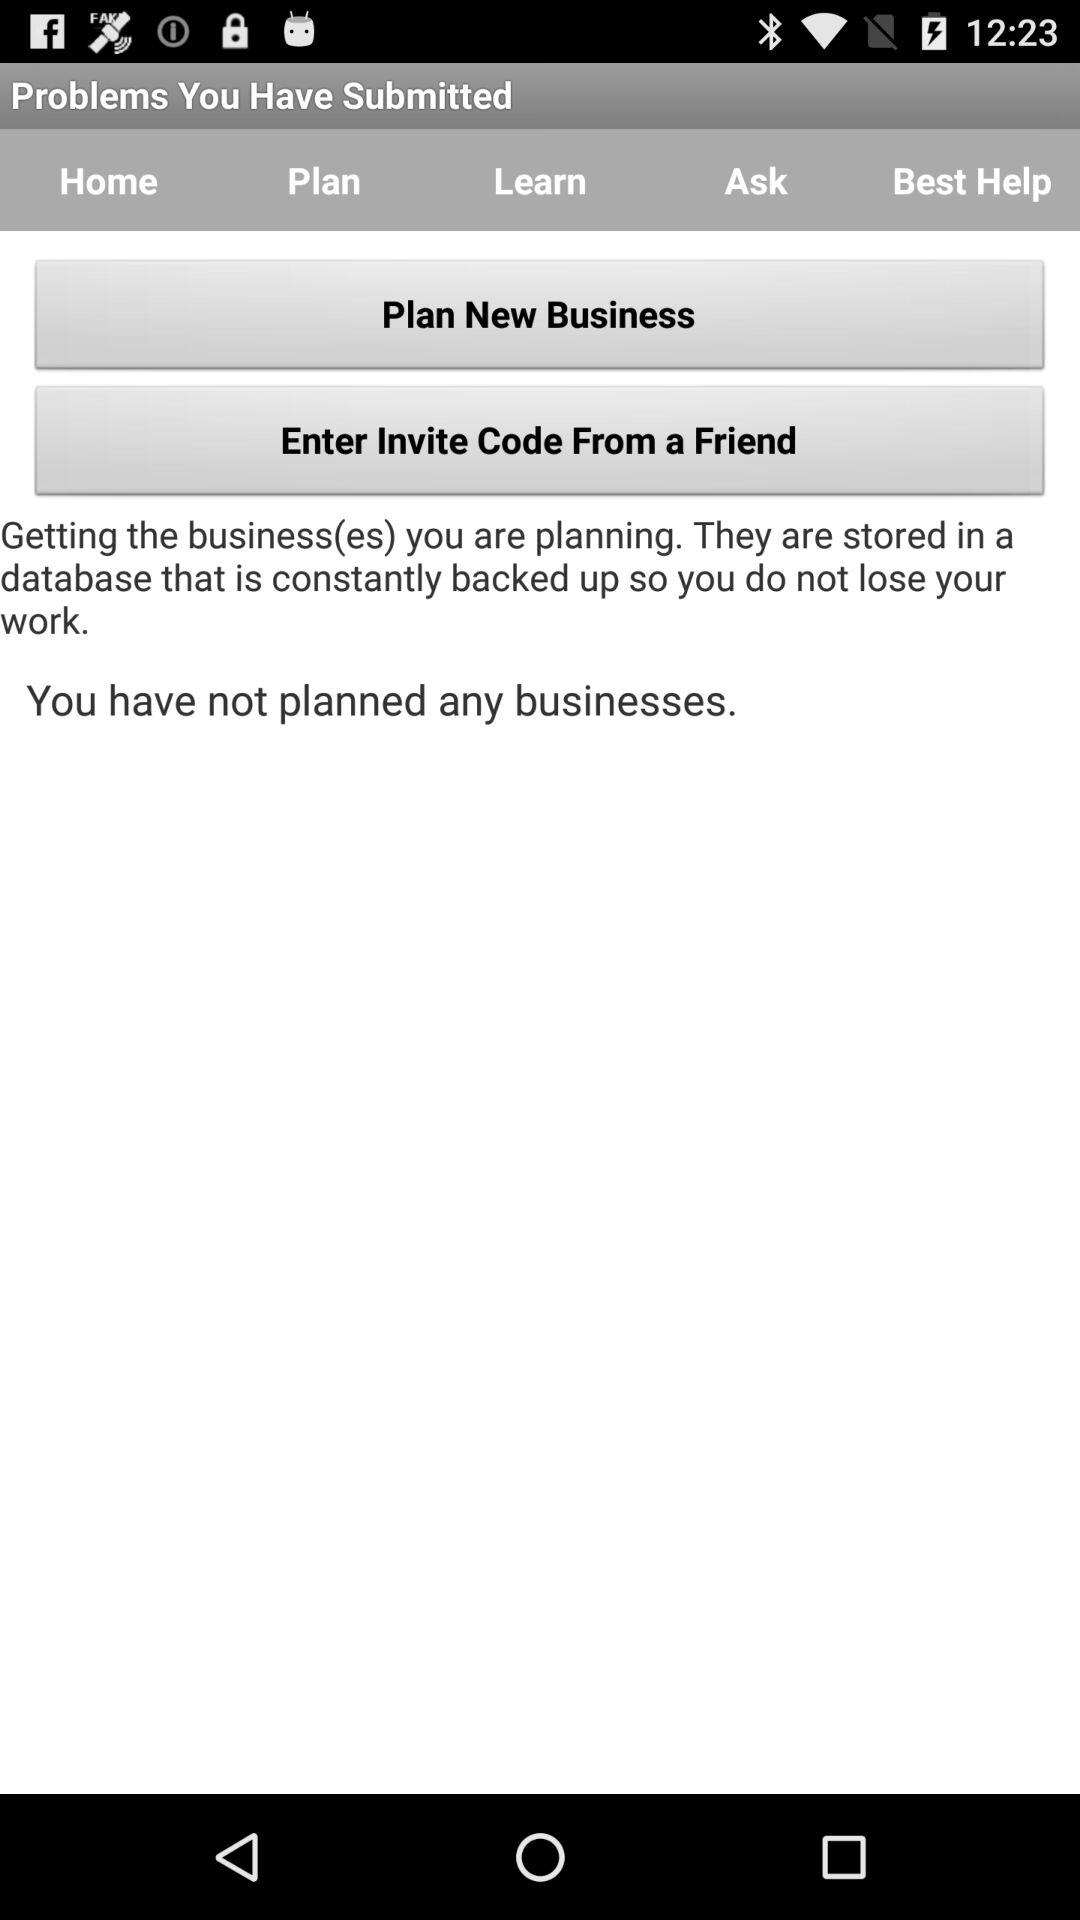How many problems have been submitted?
When the provided information is insufficient, respond with <no answer>. <no answer> 